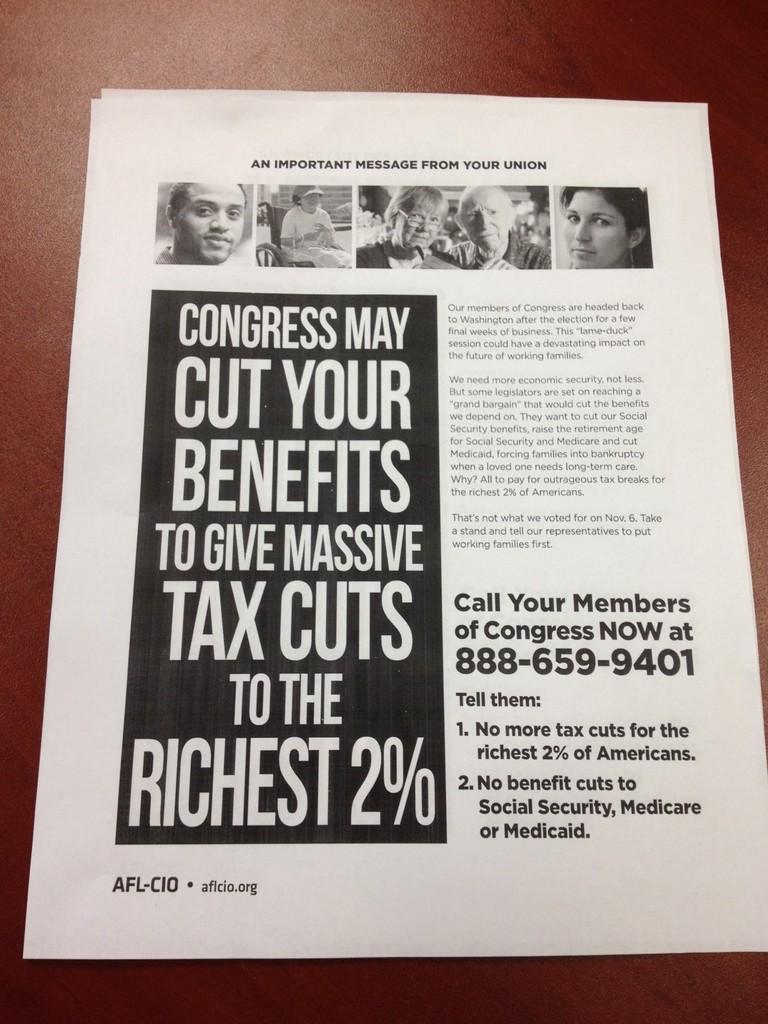What percent will get your taxes?
Give a very brief answer. 2. What is the phone number?
Your response must be concise. 888-659-9401. 